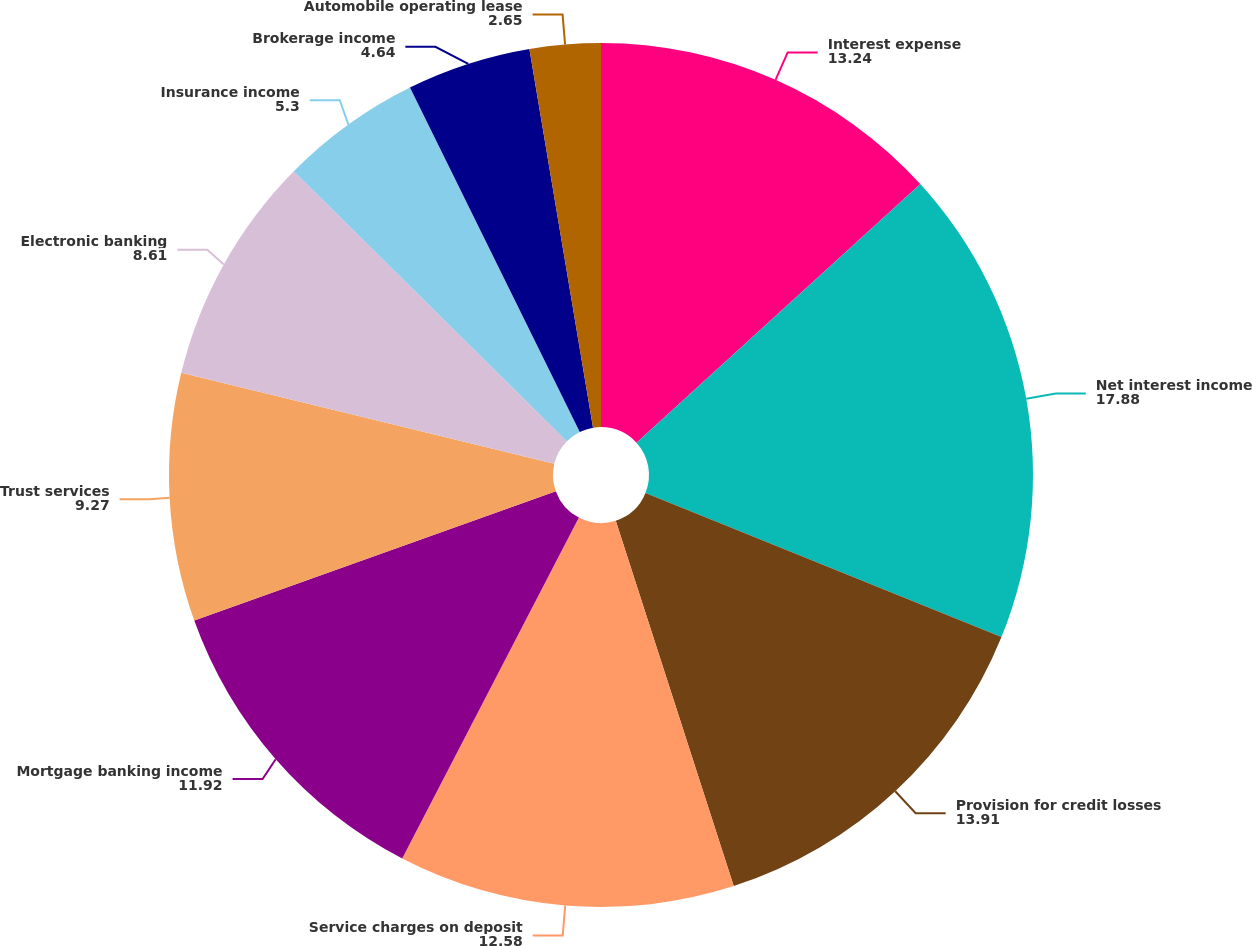<chart> <loc_0><loc_0><loc_500><loc_500><pie_chart><fcel>Interest expense<fcel>Net interest income<fcel>Provision for credit losses<fcel>Service charges on deposit<fcel>Mortgage banking income<fcel>Trust services<fcel>Electronic banking<fcel>Insurance income<fcel>Brokerage income<fcel>Automobile operating lease<nl><fcel>13.24%<fcel>17.88%<fcel>13.91%<fcel>12.58%<fcel>11.92%<fcel>9.27%<fcel>8.61%<fcel>5.3%<fcel>4.64%<fcel>2.65%<nl></chart> 